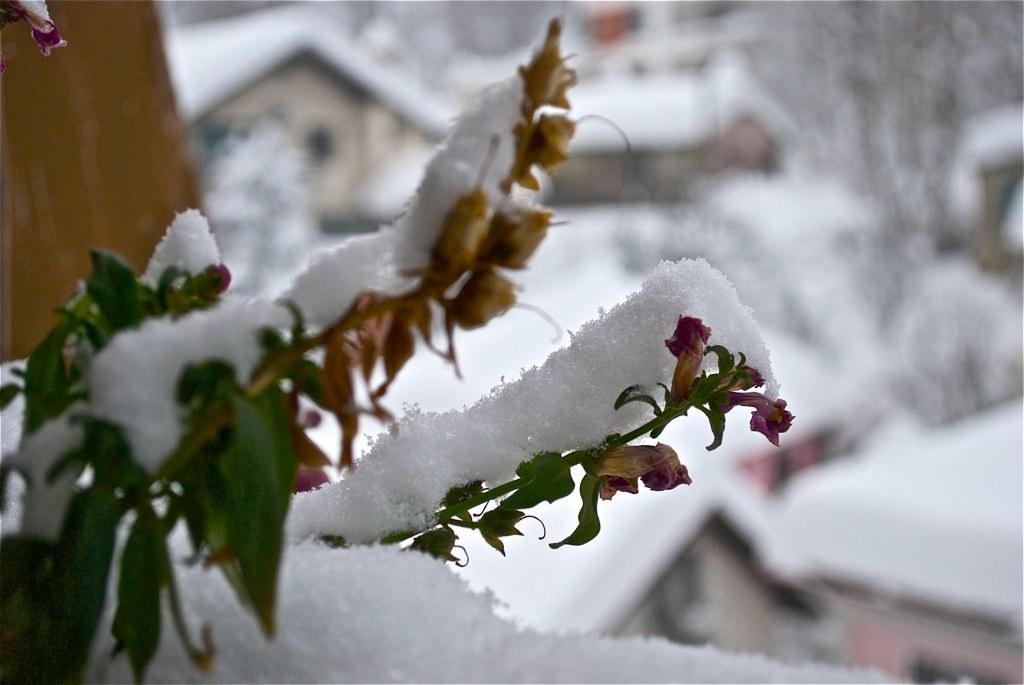What is the main subject of the image? There is a plant in the image. What is the condition of the plant? The plant is covered with snow. Can you describe the background of the image? The background of the image is blurred. What type of record can be seen on the plant in the image? There is no record present on the plant in the image. How many dimes are visible on the plant in the image? There are no dimes visible on the plant in the image. 